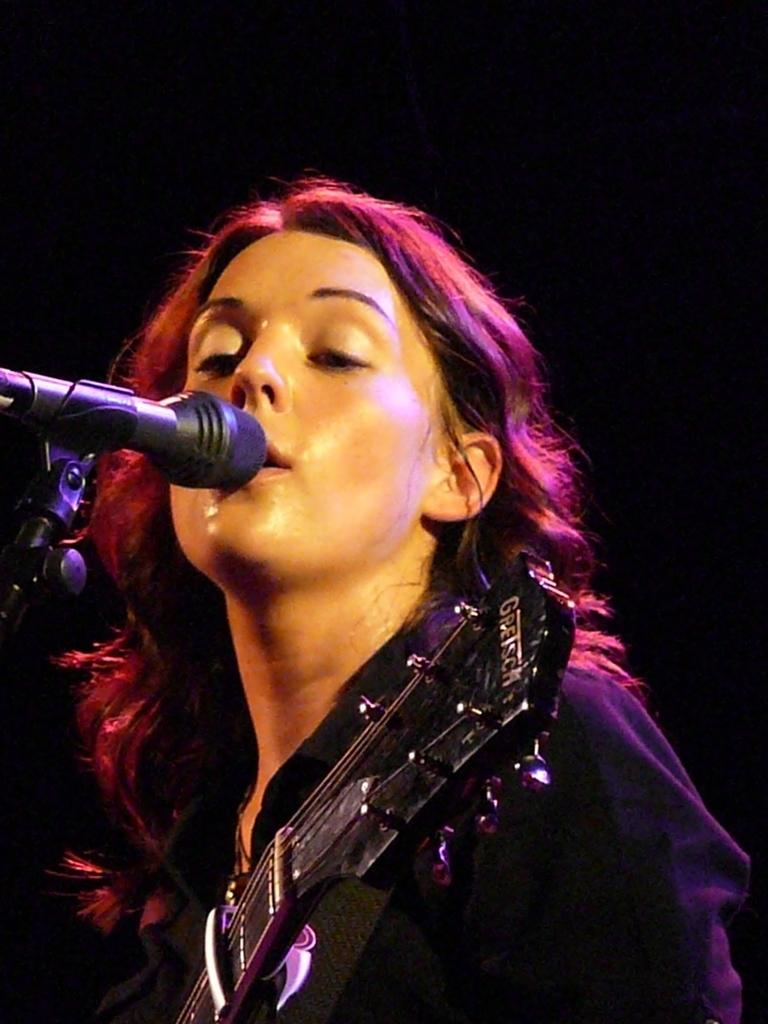Who is the main subject in the image? There is a woman in the image. What is the woman wearing? The woman is wearing a black dress. What is the woman doing in the image? The woman is singing. What object is in front of the woman? There is a microphone in front of the woman. What instrument is the woman holding? The woman is holding a guitar. What type of oatmeal is being served in the image? There is no oatmeal present in the image; it features a woman singing with a guitar and a microphone. What amusement park can be seen in the background of the image? There is no amusement park visible in the image; it focuses on the woman and her musical performance. 